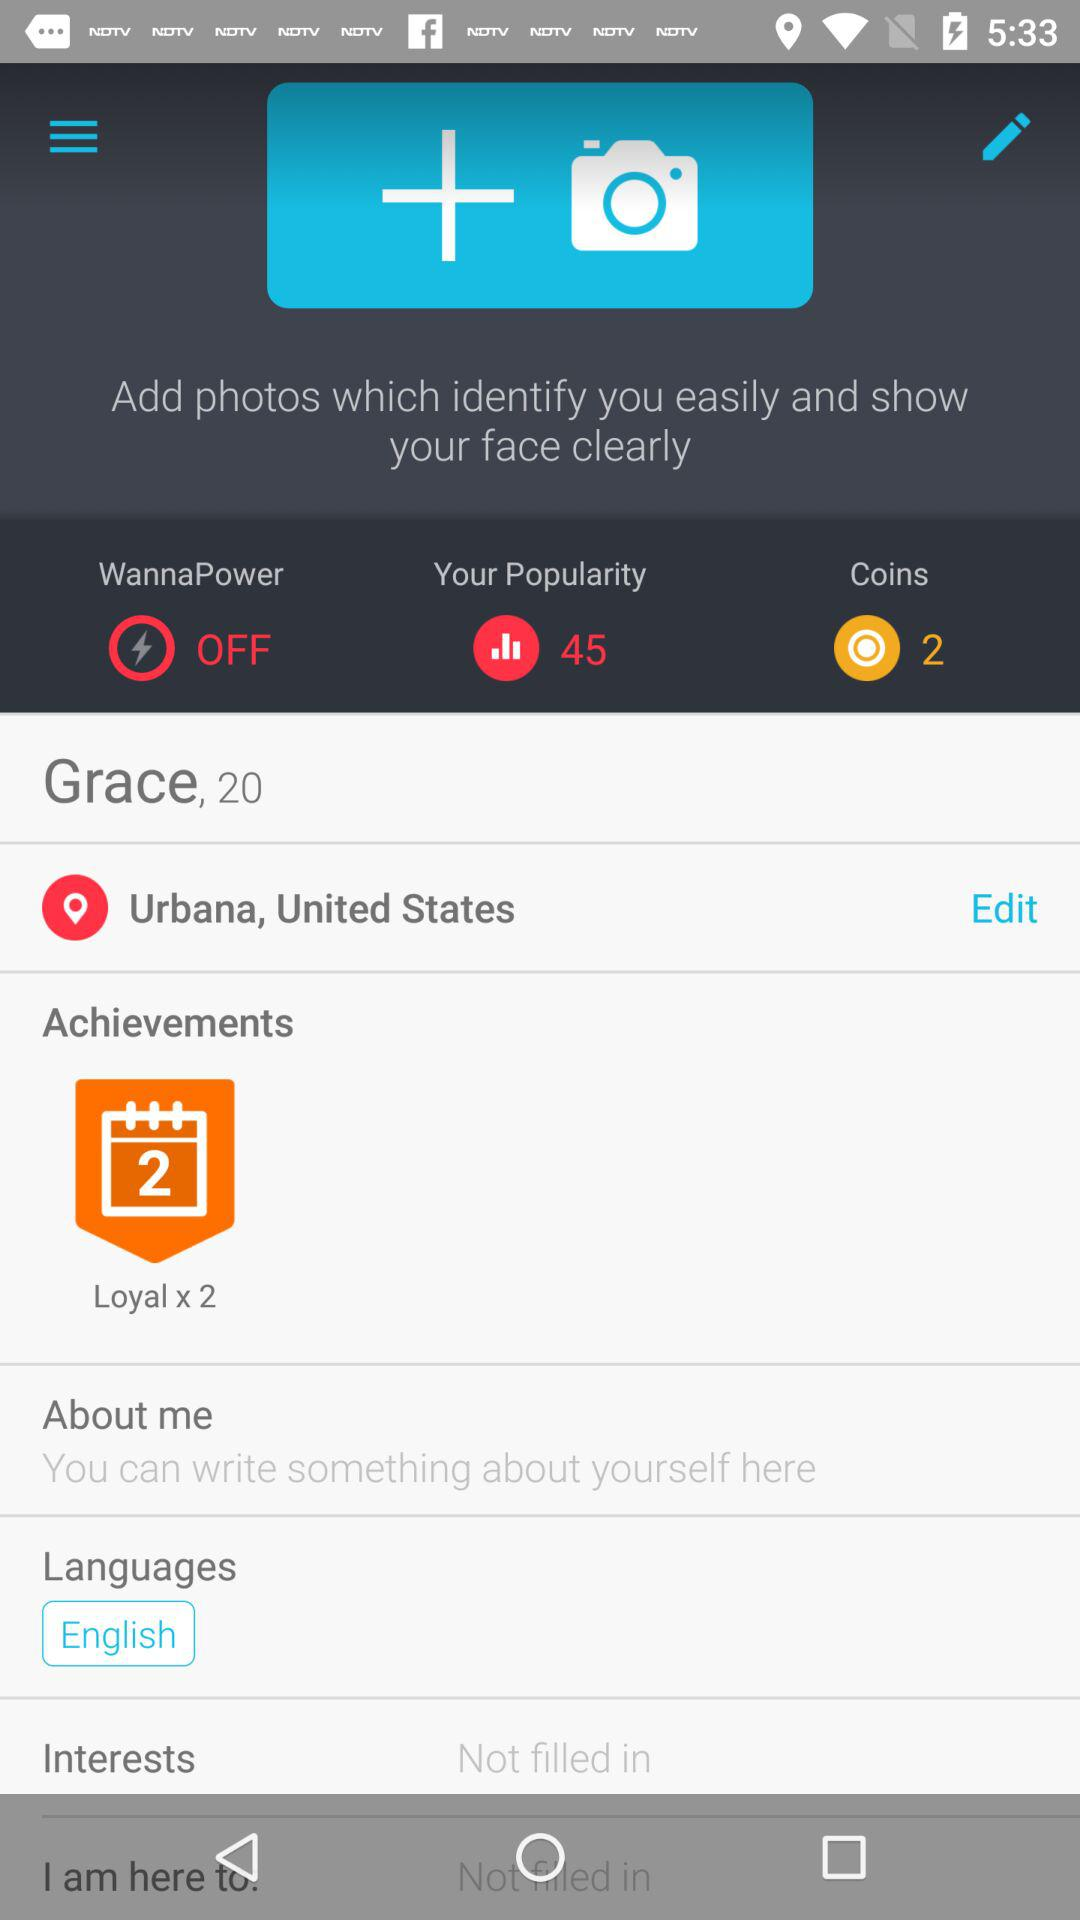What is the mentioned location? The mentioned location is Urbana, United States. 